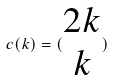Convert formula to latex. <formula><loc_0><loc_0><loc_500><loc_500>c ( k ) = ( \begin{matrix} 2 k \\ k \end{matrix} )</formula> 